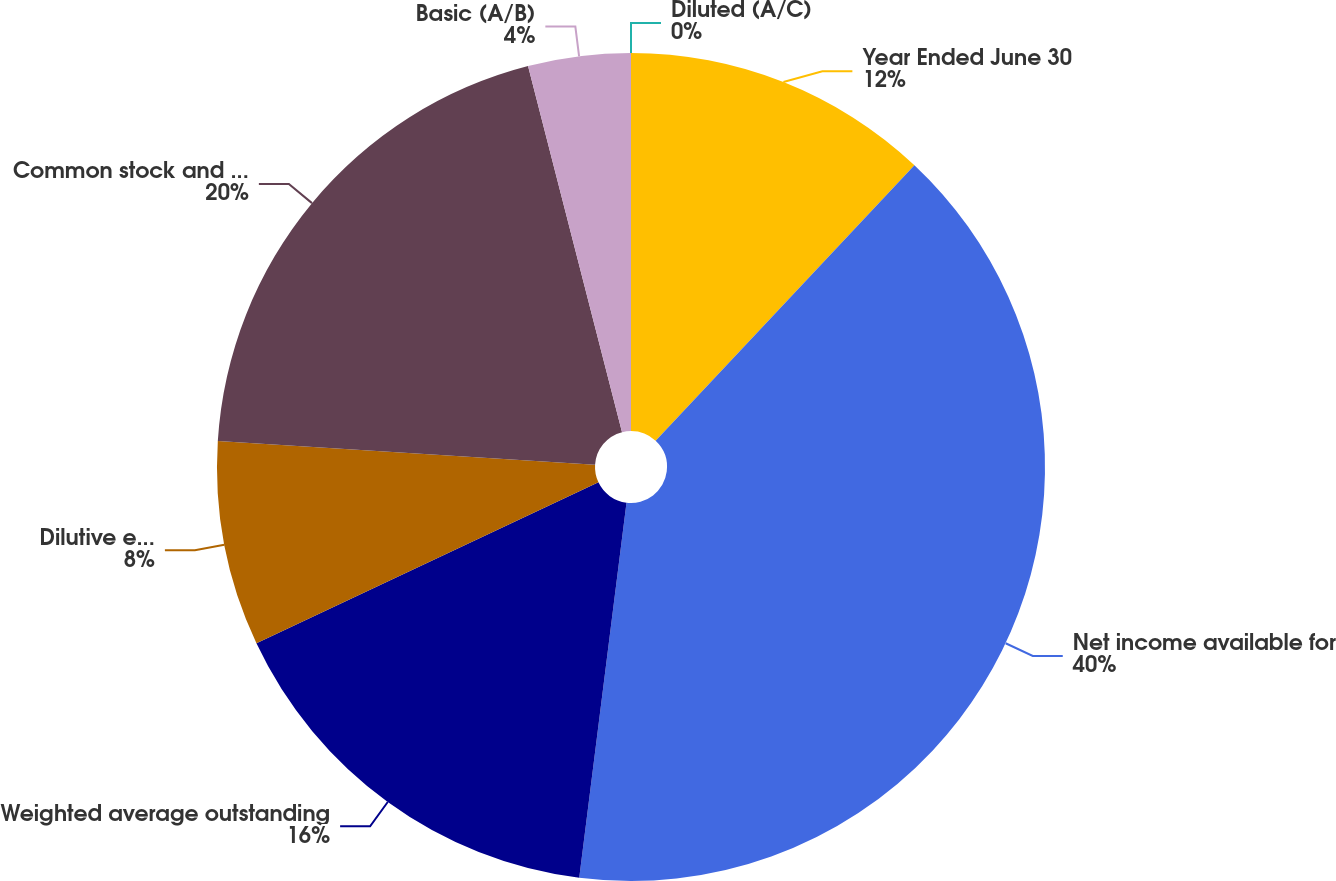Convert chart to OTSL. <chart><loc_0><loc_0><loc_500><loc_500><pie_chart><fcel>Year Ended June 30<fcel>Net income available for<fcel>Weighted average outstanding<fcel>Dilutive effect of stock-based<fcel>Common stock and common stock<fcel>Basic (A/B)<fcel>Diluted (A/C)<nl><fcel>12.0%<fcel>39.99%<fcel>16.0%<fcel>8.0%<fcel>20.0%<fcel>4.0%<fcel>0.0%<nl></chart> 